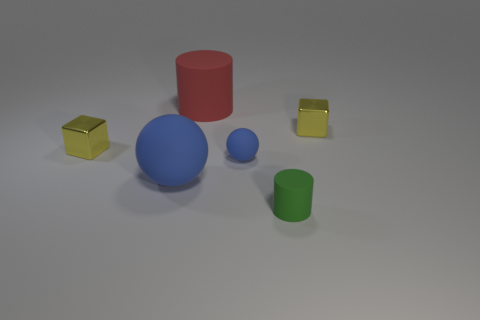Add 2 tiny yellow things. How many objects exist? 8 Subtract all cubes. How many objects are left? 4 Subtract all small blue balls. Subtract all big blue cylinders. How many objects are left? 5 Add 5 big red objects. How many big red objects are left? 6 Add 6 green cylinders. How many green cylinders exist? 7 Subtract 0 yellow cylinders. How many objects are left? 6 